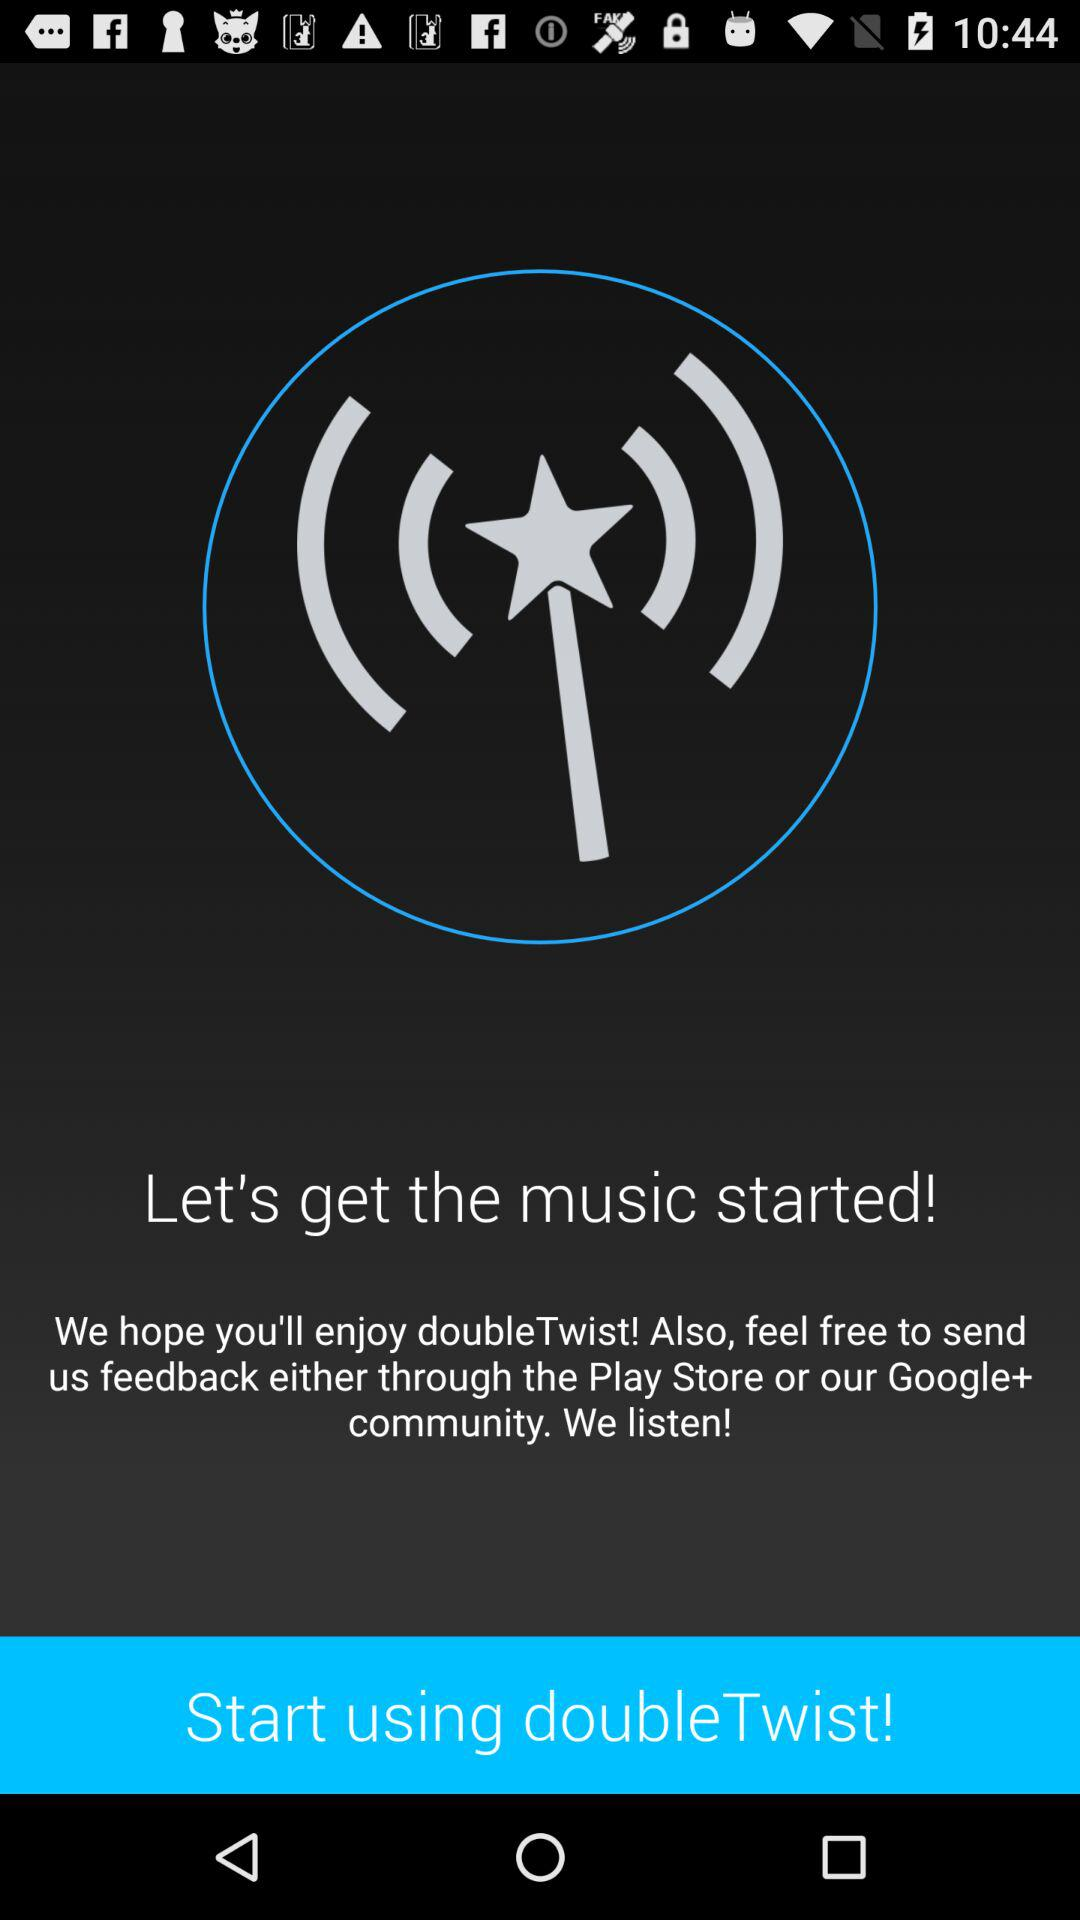Which version of the application is this?
When the provided information is insufficient, respond with <no answer>. <no answer> 